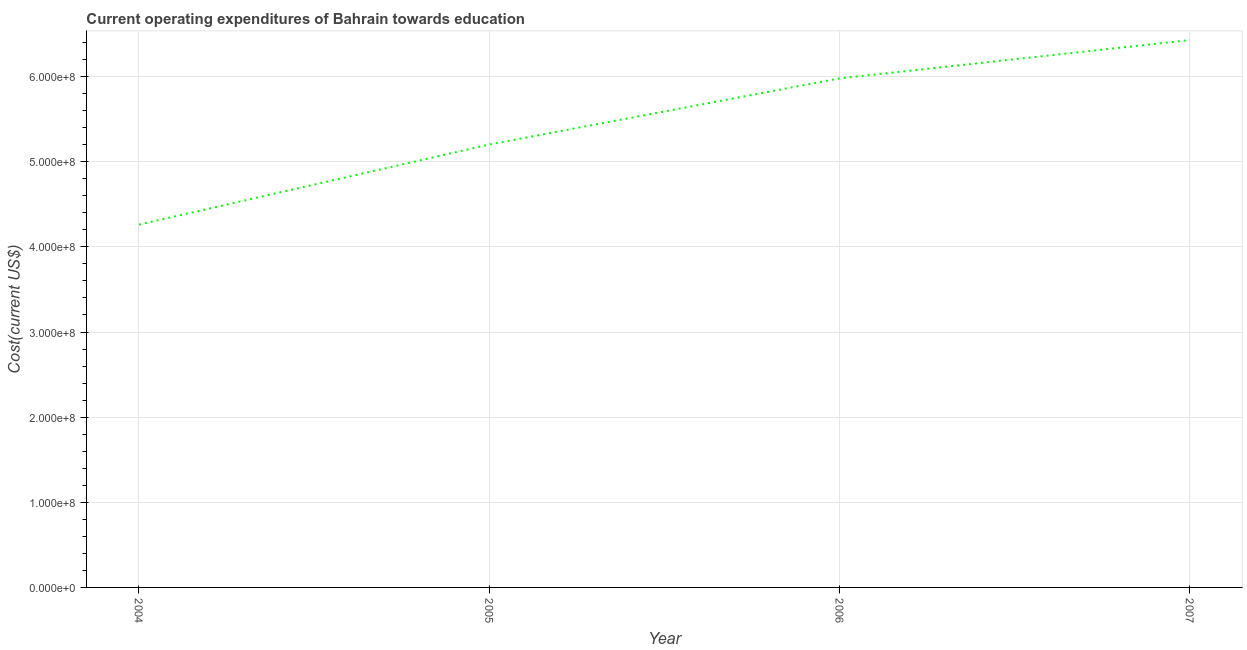What is the education expenditure in 2006?
Your answer should be compact. 5.98e+08. Across all years, what is the maximum education expenditure?
Offer a terse response. 6.43e+08. Across all years, what is the minimum education expenditure?
Your response must be concise. 4.26e+08. In which year was the education expenditure maximum?
Keep it short and to the point. 2007. What is the sum of the education expenditure?
Give a very brief answer. 2.19e+09. What is the difference between the education expenditure in 2004 and 2005?
Provide a short and direct response. -9.41e+07. What is the average education expenditure per year?
Provide a short and direct response. 5.47e+08. What is the median education expenditure?
Your answer should be compact. 5.59e+08. In how many years, is the education expenditure greater than 240000000 US$?
Your response must be concise. 4. What is the ratio of the education expenditure in 2004 to that in 2006?
Provide a short and direct response. 0.71. Is the difference between the education expenditure in 2004 and 2006 greater than the difference between any two years?
Provide a short and direct response. No. What is the difference between the highest and the second highest education expenditure?
Your response must be concise. 4.50e+07. What is the difference between the highest and the lowest education expenditure?
Offer a very short reply. 2.17e+08. In how many years, is the education expenditure greater than the average education expenditure taken over all years?
Offer a terse response. 2. What is the difference between two consecutive major ticks on the Y-axis?
Give a very brief answer. 1.00e+08. Does the graph contain grids?
Provide a succinct answer. Yes. What is the title of the graph?
Your response must be concise. Current operating expenditures of Bahrain towards education. What is the label or title of the X-axis?
Ensure brevity in your answer.  Year. What is the label or title of the Y-axis?
Provide a succinct answer. Cost(current US$). What is the Cost(current US$) of 2004?
Your response must be concise. 4.26e+08. What is the Cost(current US$) in 2005?
Offer a very short reply. 5.20e+08. What is the Cost(current US$) in 2006?
Ensure brevity in your answer.  5.98e+08. What is the Cost(current US$) in 2007?
Your answer should be very brief. 6.43e+08. What is the difference between the Cost(current US$) in 2004 and 2005?
Offer a very short reply. -9.41e+07. What is the difference between the Cost(current US$) in 2004 and 2006?
Offer a terse response. -1.72e+08. What is the difference between the Cost(current US$) in 2004 and 2007?
Give a very brief answer. -2.17e+08. What is the difference between the Cost(current US$) in 2005 and 2006?
Your answer should be very brief. -7.77e+07. What is the difference between the Cost(current US$) in 2005 and 2007?
Ensure brevity in your answer.  -1.23e+08. What is the difference between the Cost(current US$) in 2006 and 2007?
Your answer should be very brief. -4.50e+07. What is the ratio of the Cost(current US$) in 2004 to that in 2005?
Your answer should be very brief. 0.82. What is the ratio of the Cost(current US$) in 2004 to that in 2006?
Keep it short and to the point. 0.71. What is the ratio of the Cost(current US$) in 2004 to that in 2007?
Offer a very short reply. 0.66. What is the ratio of the Cost(current US$) in 2005 to that in 2006?
Give a very brief answer. 0.87. What is the ratio of the Cost(current US$) in 2005 to that in 2007?
Provide a succinct answer. 0.81. What is the ratio of the Cost(current US$) in 2006 to that in 2007?
Ensure brevity in your answer.  0.93. 